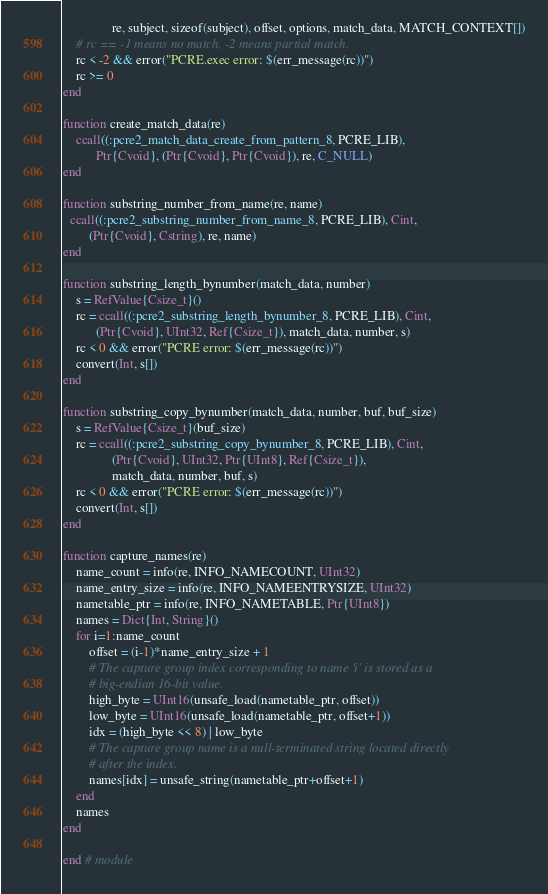<code> <loc_0><loc_0><loc_500><loc_500><_Julia_>               re, subject, sizeof(subject), offset, options, match_data, MATCH_CONTEXT[])
    # rc == -1 means no match, -2 means partial match.
    rc < -2 && error("PCRE.exec error: $(err_message(rc))")
    rc >= 0
end

function create_match_data(re)
    ccall((:pcre2_match_data_create_from_pattern_8, PCRE_LIB),
          Ptr{Cvoid}, (Ptr{Cvoid}, Ptr{Cvoid}), re, C_NULL)
end

function substring_number_from_name(re, name)
  ccall((:pcre2_substring_number_from_name_8, PCRE_LIB), Cint,
        (Ptr{Cvoid}, Cstring), re, name)
end

function substring_length_bynumber(match_data, number)
    s = RefValue{Csize_t}()
    rc = ccall((:pcre2_substring_length_bynumber_8, PCRE_LIB), Cint,
          (Ptr{Cvoid}, UInt32, Ref{Csize_t}), match_data, number, s)
    rc < 0 && error("PCRE error: $(err_message(rc))")
    convert(Int, s[])
end

function substring_copy_bynumber(match_data, number, buf, buf_size)
    s = RefValue{Csize_t}(buf_size)
    rc = ccall((:pcre2_substring_copy_bynumber_8, PCRE_LIB), Cint,
               (Ptr{Cvoid}, UInt32, Ptr{UInt8}, Ref{Csize_t}),
               match_data, number, buf, s)
    rc < 0 && error("PCRE error: $(err_message(rc))")
    convert(Int, s[])
end

function capture_names(re)
    name_count = info(re, INFO_NAMECOUNT, UInt32)
    name_entry_size = info(re, INFO_NAMEENTRYSIZE, UInt32)
    nametable_ptr = info(re, INFO_NAMETABLE, Ptr{UInt8})
    names = Dict{Int, String}()
    for i=1:name_count
        offset = (i-1)*name_entry_size + 1
        # The capture group index corresponding to name 'i' is stored as a
        # big-endian 16-bit value.
        high_byte = UInt16(unsafe_load(nametable_ptr, offset))
        low_byte = UInt16(unsafe_load(nametable_ptr, offset+1))
        idx = (high_byte << 8) | low_byte
        # The capture group name is a null-terminated string located directly
        # after the index.
        names[idx] = unsafe_string(nametable_ptr+offset+1)
    end
    names
end

end # module
</code> 